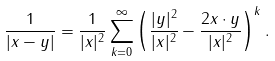<formula> <loc_0><loc_0><loc_500><loc_500>\frac { 1 } { | x - y | } = \frac { 1 } { | x | ^ { 2 } } \sum _ { k = 0 } ^ { \infty } \left ( \frac { | y | ^ { 2 } } { | x | ^ { 2 } } - \frac { 2 x \cdot y } { | x | ^ { 2 } } \right ) ^ { k } .</formula> 